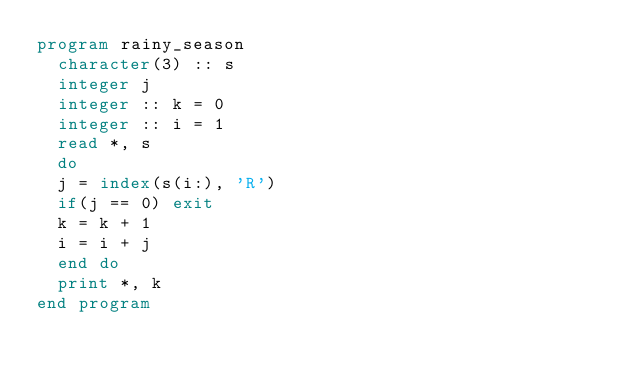<code> <loc_0><loc_0><loc_500><loc_500><_FORTRAN_>program rainy_season
  character(3) :: s
  integer j
  integer :: k = 0
  integer :: i = 1
  read *, s
  do
  j = index(s(i:), 'R')
  if(j == 0) exit
  k = k + 1
  i = i + j
  end do
  print *, k
end program</code> 